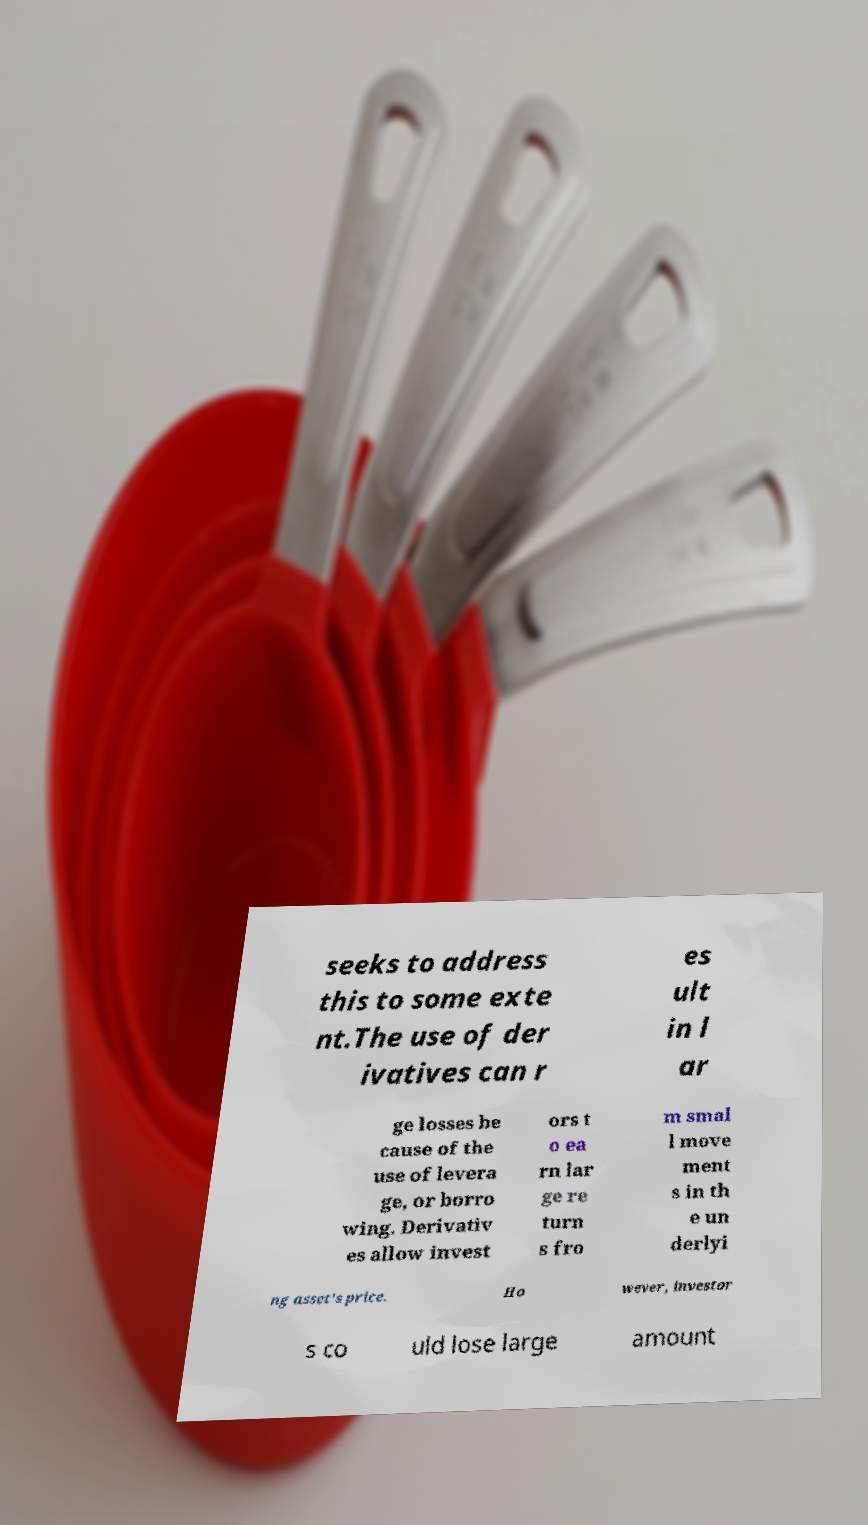Please read and relay the text visible in this image. What does it say? seeks to address this to some exte nt.The use of der ivatives can r es ult in l ar ge losses be cause of the use of levera ge, or borro wing. Derivativ es allow invest ors t o ea rn lar ge re turn s fro m smal l move ment s in th e un derlyi ng asset's price. Ho wever, investor s co uld lose large amount 